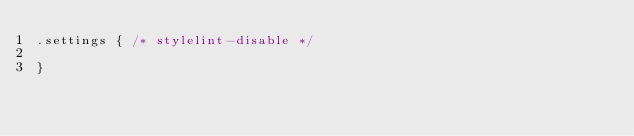Convert code to text. <code><loc_0><loc_0><loc_500><loc_500><_CSS_>.settings { /* stylelint-disable */

}
</code> 